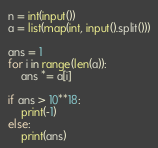Convert code to text. <code><loc_0><loc_0><loc_500><loc_500><_Python_>n = int(input())
a = list(map(int, input().split()))

ans = 1
for i in range(len(a)):
    ans *= a[i]

if ans > 10**18:
    print(-1)
else:
    print(ans)

</code> 